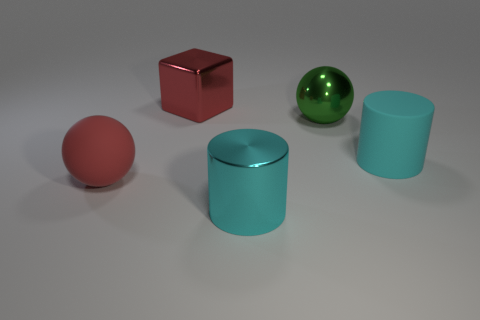Add 4 large red cubes. How many objects exist? 9 Subtract all cylinders. How many objects are left? 3 Add 5 big cyan rubber cylinders. How many big cyan rubber cylinders exist? 6 Subtract 0 gray cylinders. How many objects are left? 5 Subtract all spheres. Subtract all metal cylinders. How many objects are left? 2 Add 1 red metallic cubes. How many red metallic cubes are left? 2 